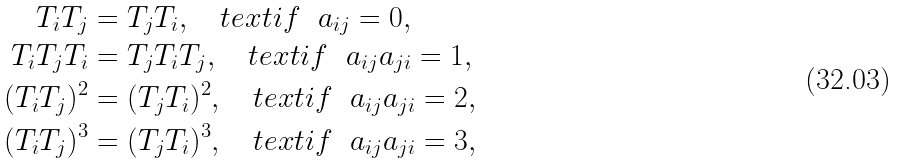Convert formula to latex. <formula><loc_0><loc_0><loc_500><loc_500>T _ { i } T _ { j } & = T _ { j } T _ { i } , \quad t e x t { i f } \ \ a _ { i j } = 0 , \\ T _ { i } T _ { j } T _ { i } & = T _ { j } T _ { i } T _ { j } , \quad t e x t { i f } \ \ a _ { i j } a _ { j i } = 1 , \\ ( T _ { i } T _ { j } ) ^ { 2 } & = ( T _ { j } T _ { i } ) ^ { 2 } , \quad t e x t { i f } \ \ a _ { i j } a _ { j i } = 2 , \\ ( T _ { i } T _ { j } ) ^ { 3 } & = ( T _ { j } T _ { i } ) ^ { 3 } , \quad t e x t { i f } \ \ a _ { i j } a _ { j i } = 3 ,</formula> 